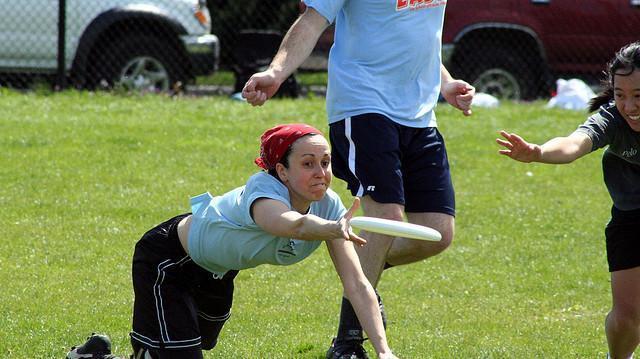How many vehicles are in the background?
Give a very brief answer. 2. How many trucks are in the photo?
Give a very brief answer. 2. How many people can you see?
Give a very brief answer. 3. 